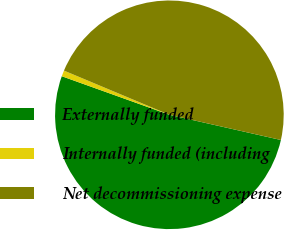Convert chart to OTSL. <chart><loc_0><loc_0><loc_500><loc_500><pie_chart><fcel>Externally funded<fcel>Internally funded (including<fcel>Net decommissioning expense<nl><fcel>51.94%<fcel>0.84%<fcel>47.22%<nl></chart> 